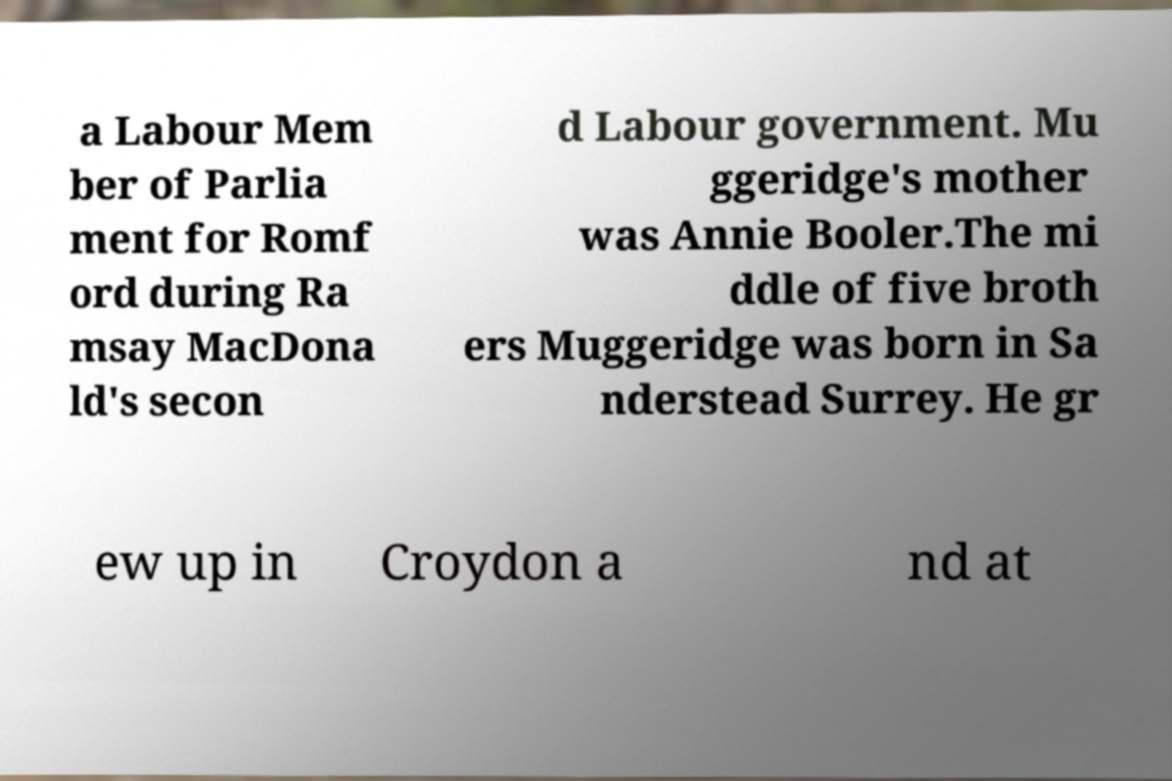Could you extract and type out the text from this image? a Labour Mem ber of Parlia ment for Romf ord during Ra msay MacDona ld's secon d Labour government. Mu ggeridge's mother was Annie Booler.The mi ddle of five broth ers Muggeridge was born in Sa nderstead Surrey. He gr ew up in Croydon a nd at 